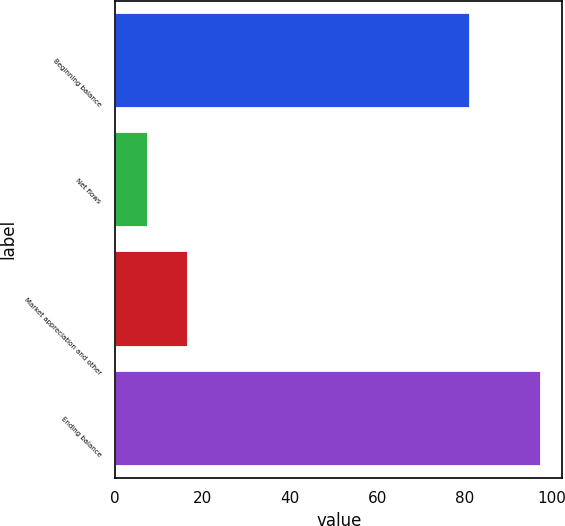Convert chart. <chart><loc_0><loc_0><loc_500><loc_500><bar_chart><fcel>Beginning balance<fcel>Net flows<fcel>Market appreciation and other<fcel>Ending balance<nl><fcel>81.3<fcel>7.6<fcel>16.59<fcel>97.5<nl></chart> 